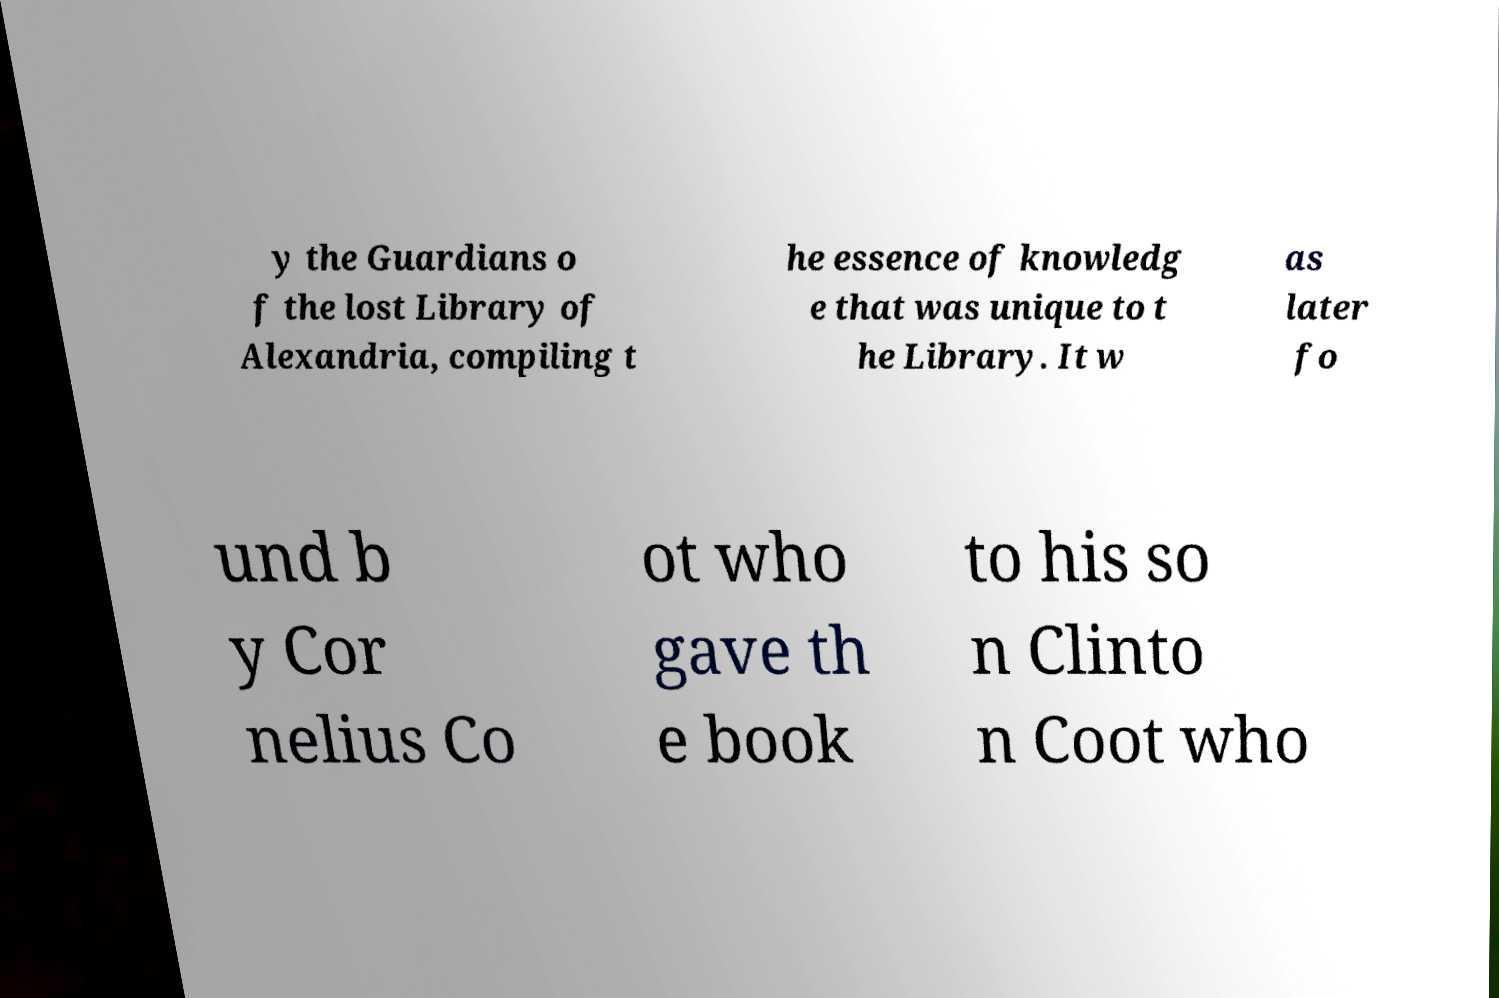Could you extract and type out the text from this image? y the Guardians o f the lost Library of Alexandria, compiling t he essence of knowledg e that was unique to t he Library. It w as later fo und b y Cor nelius Co ot who gave th e book to his so n Clinto n Coot who 